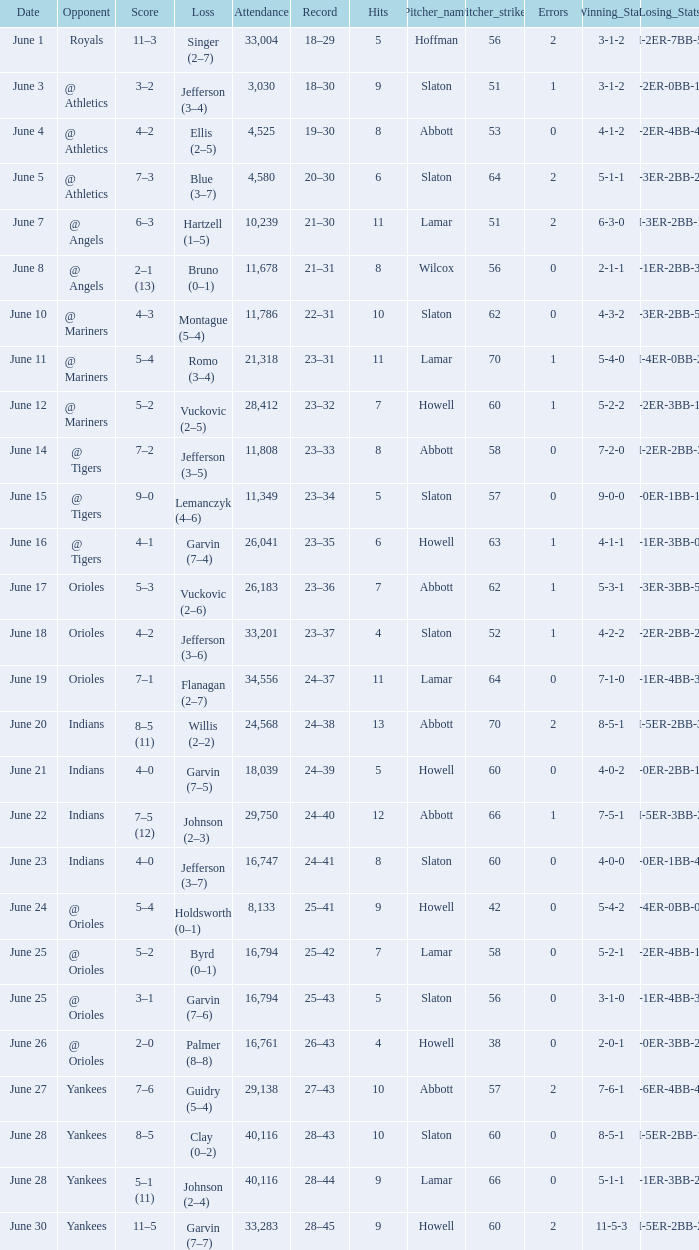Who was the opponent at the game when the record was 28–45? Yankees. 